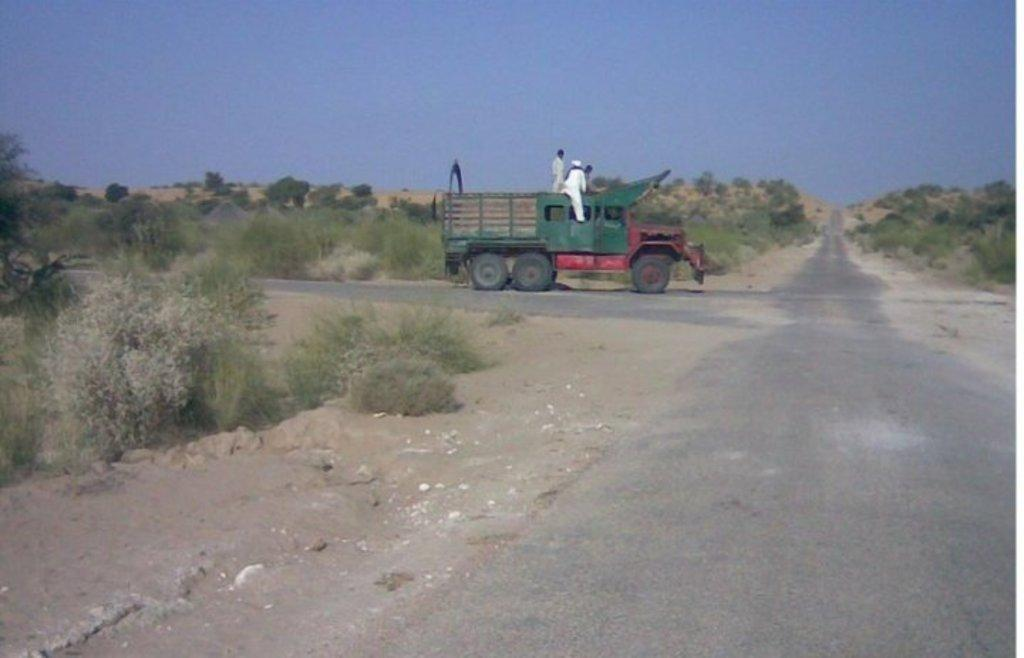What is the main feature of the image? There is a road in the image. Are there any living beings in the image? Yes, there are people in the image. What else can be seen on the road? There is a vehicle in the image. What type of natural environment is visible in the image? There is grass and trees visible in the image. What is the condition of the sky in the image? Clouds are present in the sky in the image. What type of decision can be seen being made by the cakes in the image? There are no cakes present in the image, so no decisions can be made by them. What type of fiction is being depicted in the image? The image does not depict any fiction; it shows a road, people, a vehicle, grass, trees, and clouds. 